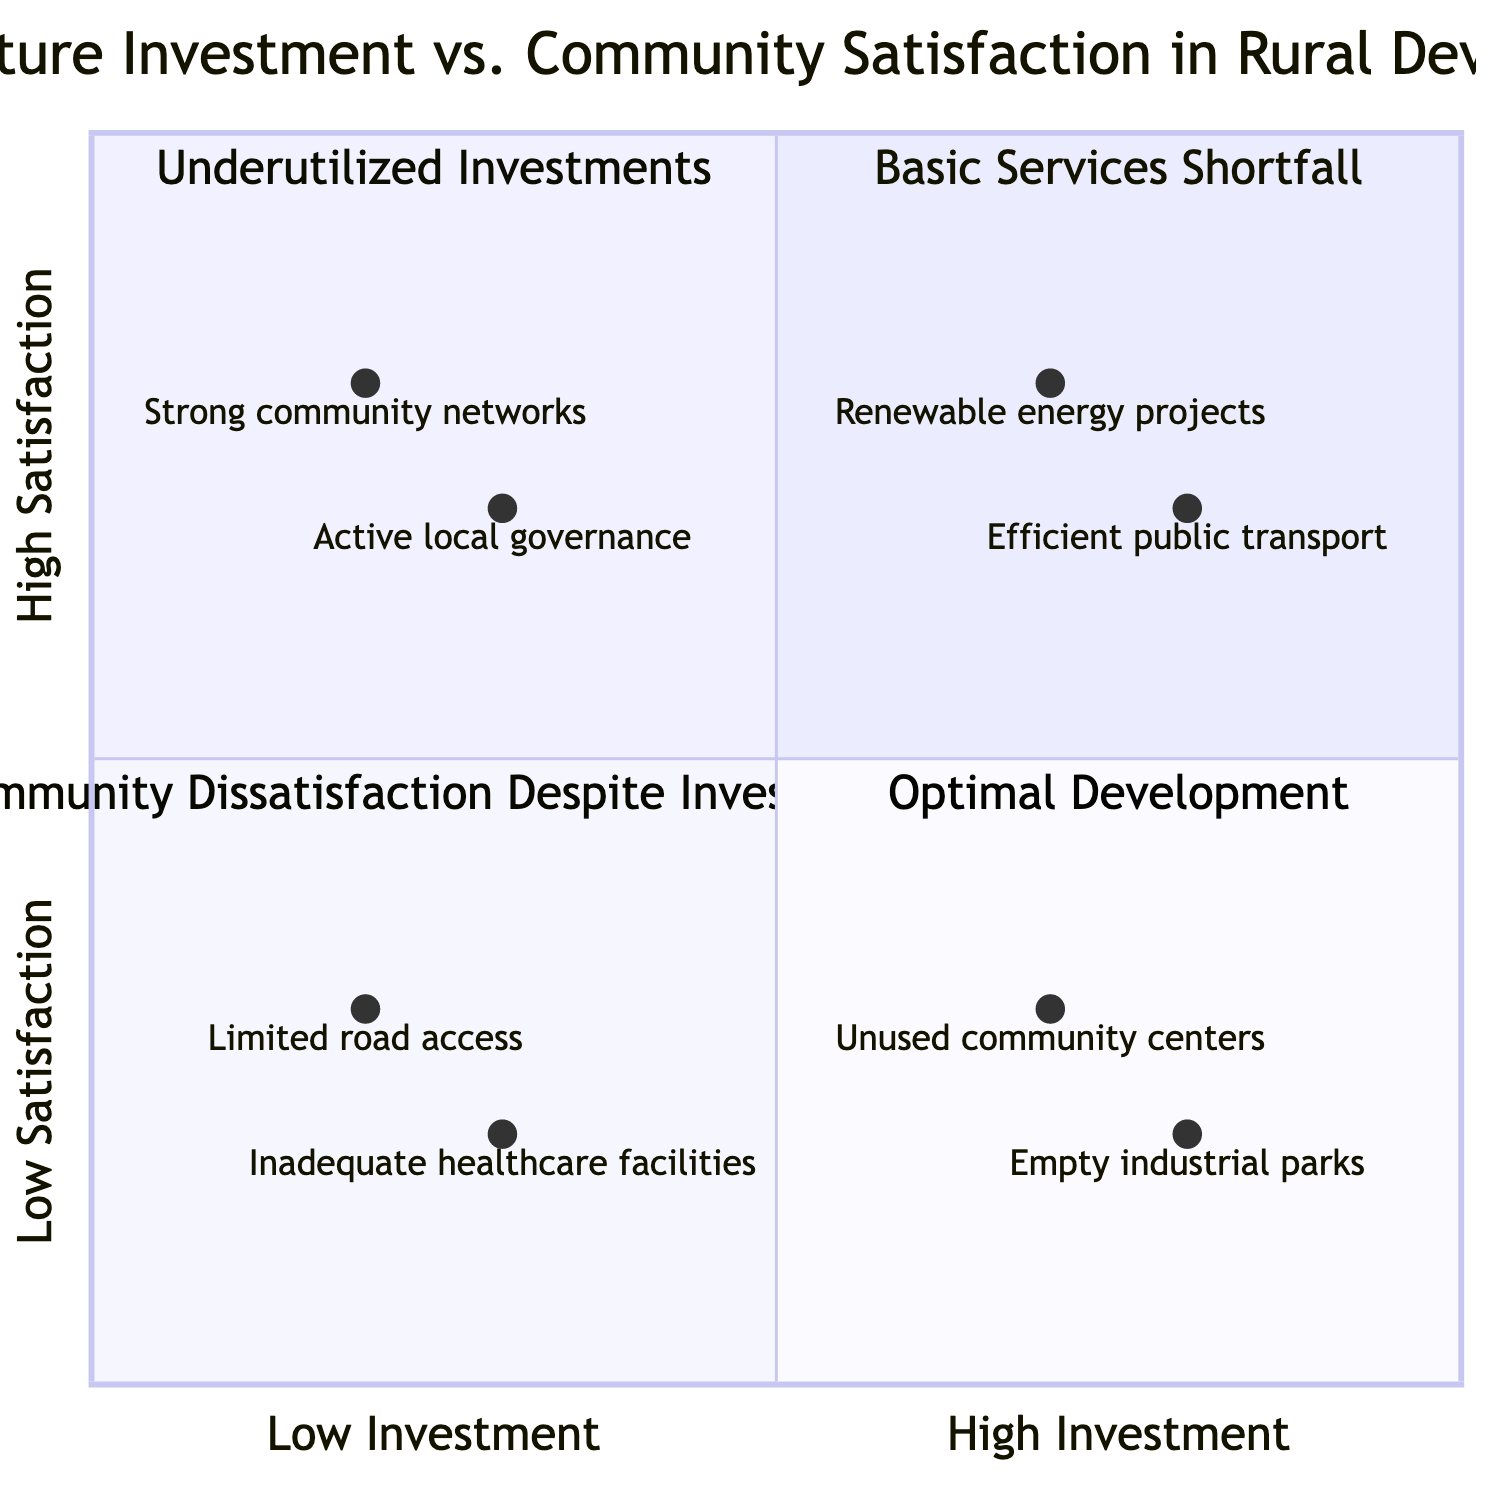What quadrant includes limited road access? Limited road access is categorized in the "Basic Services Shortfall" quadrant, which represents areas with low infrastructure investment and low community satisfaction.
Answer: Basic Services Shortfall How many nodes are in the "Underutilized Investments" quadrant? The "Underutilized Investments" quadrant contains two examples: unused community centers and empty industrial parks, resulting in two nodes.
Answer: 2 What is the primary reason for high community satisfaction in the "Community Dissatisfaction Despite Investments" quadrant? High community satisfaction in this quadrant is attributed to non-infrastructure-related factors, such as active local governance and strong community networks, which provide social support even with low investment.
Answer: Non-infrastructure-related factors Which quadrant has examples of renewable energy projects? Renewable energy projects are found in the "Optimal Development" quadrant, where both infrastructure investment and community satisfaction are high.
Answer: Optimal Development How does community satisfaction relate to infrastructure investment in the "Optimal Development" quadrant? In the "Optimal Development" quadrant, there is a strong positive correlation, as both infrastructure investment and community satisfaction are high, indicating that effective investments lead to satisfaction.
Answer: High correlation How many examples are in the "Basic Services Shortfall" quadrant? The "Basic Services Shortfall" quadrant includes two examples: limited road access and inadequate healthcare facilities, totaling two examples.
Answer: 2 Which quadrant is characterized by both high investment and low satisfaction? The quadrant known for high infrastructure investment but low community satisfaction is called "Underutilized Investments."
Answer: Underutilized Investments What two examples show community satisfaction despite low infrastructure investment? The examples showing community satisfaction despite low infrastructure investment are active local governance and strong community networks.
Answer: Active local governance, strong community networks 